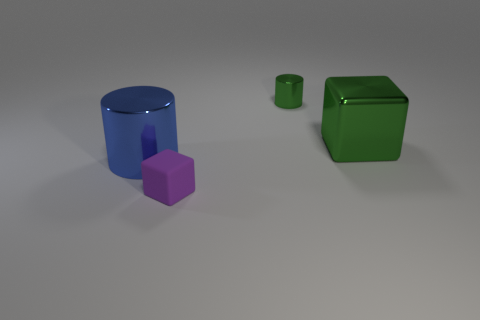Add 1 yellow cylinders. How many objects exist? 5 Subtract all brown cylinders. Subtract all brown balls. How many cylinders are left? 2 Subtract all big cyan spheres. Subtract all big things. How many objects are left? 2 Add 1 small rubber objects. How many small rubber objects are left? 2 Add 1 large green metallic blocks. How many large green metallic blocks exist? 2 Subtract all green cylinders. How many cylinders are left? 1 Subtract 0 gray blocks. How many objects are left? 4 Subtract 2 cylinders. How many cylinders are left? 0 